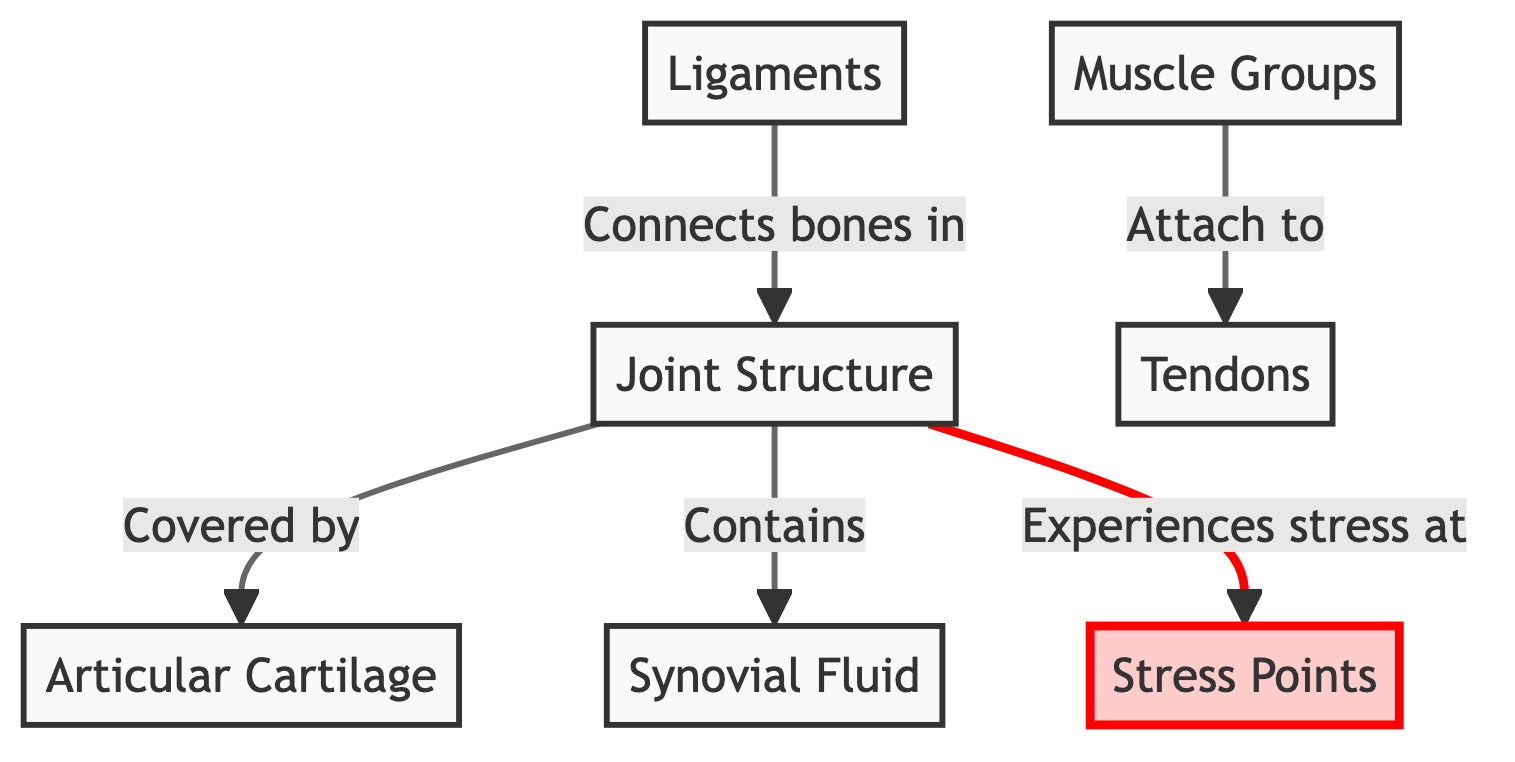What is the color of the joint structure node? The joint structure node is highlighted in blue, indicated by the style property that assigns a fill color of light blue (#e6f3ff) and a stroke color of dark blue (#0066cc).
Answer: Blue How many nodes are highlighted in the diagram? The diagram contains one highlighted node, which is the stress points node, denoted by a fill color of light pink (#ffe6f2) and a stroke color of dark pink (#cc0066).
Answer: One What connects the bones in the joint structure? The ligaments connect the bones in the joint structure as shown in the flow from the ligaments node to the joint structure node, indicating the relationship.
Answer: Ligaments Which component experiences stress at specific points? The joint structure experiences stress at specific points, as noted by the connection leading to the stress points node.
Answer: Joint Structure Which component is covered by articular cartilage? The joint structure is covered by articular cartilage, as indicated by the connection depicting that relationship in the diagram.
Answer: Joint Structure How is synovial fluid displayed in the diagram? The synovial fluid is displayed in green with a fill color of light green (#e6fff2) and a stroke color of dark green (#00cc66), representing its distinct component in the joint anatomy.
Answer: Green What is the role of tendons in relation to muscle groups? Tendons attach to muscle groups indicating their role as connectors between muscles and bones, as shown in the relationship from the muscle groups node to the tendons node.
Answer: Attach Which node directly indicates stress points? The stress points node directly indicates the areas where stress is experienced within the joint structure. This is outlined through the flow from the joint structure node to the stress points node.
Answer: Stress Points What links the muscle groups to tendons? The relationship linking the muscle groups to tendons is indicated by the connection labeled "Attach to," highlighting how muscles influence tendon function.
Answer: Attach to 